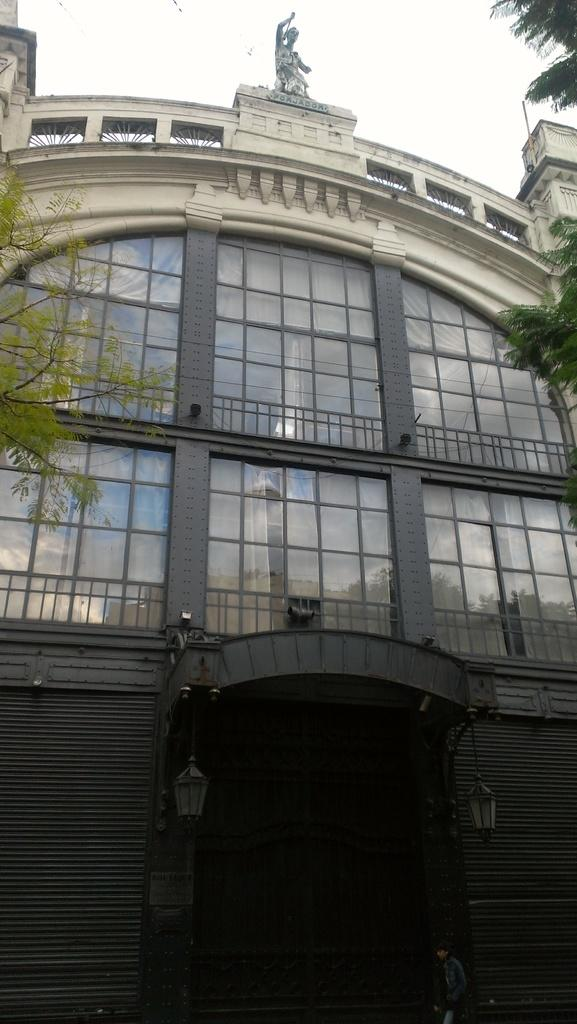What is the main subject in the foreground of the image? There is a building in the foreground of the image. What can be seen on either side of the building? There are trees on either side of the building. What is visible at the top of the image? The sky is visible at the top of the image. What is the price of the ornament hanging from the chin of the person in the image? There is no person or ornament present in the image; it features a building with trees on either side and a visible sky. 